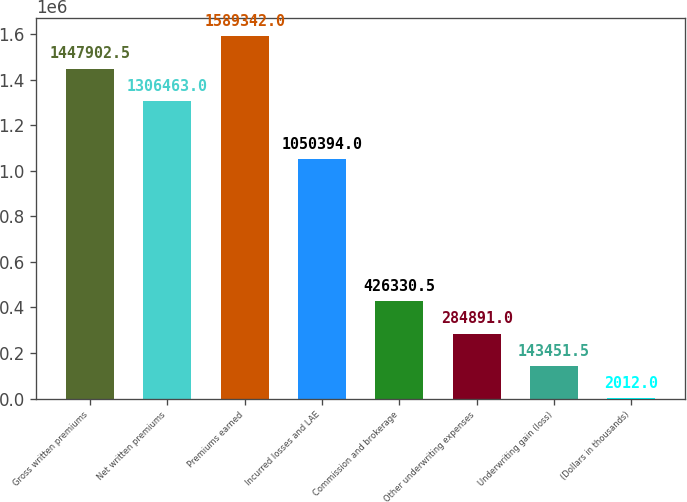Convert chart to OTSL. <chart><loc_0><loc_0><loc_500><loc_500><bar_chart><fcel>Gross written premiums<fcel>Net written premiums<fcel>Premiums earned<fcel>Incurred losses and LAE<fcel>Commission and brokerage<fcel>Other underwriting expenses<fcel>Underwriting gain (loss)<fcel>(Dollars in thousands)<nl><fcel>1.4479e+06<fcel>1.30646e+06<fcel>1.58934e+06<fcel>1.05039e+06<fcel>426330<fcel>284891<fcel>143452<fcel>2012<nl></chart> 